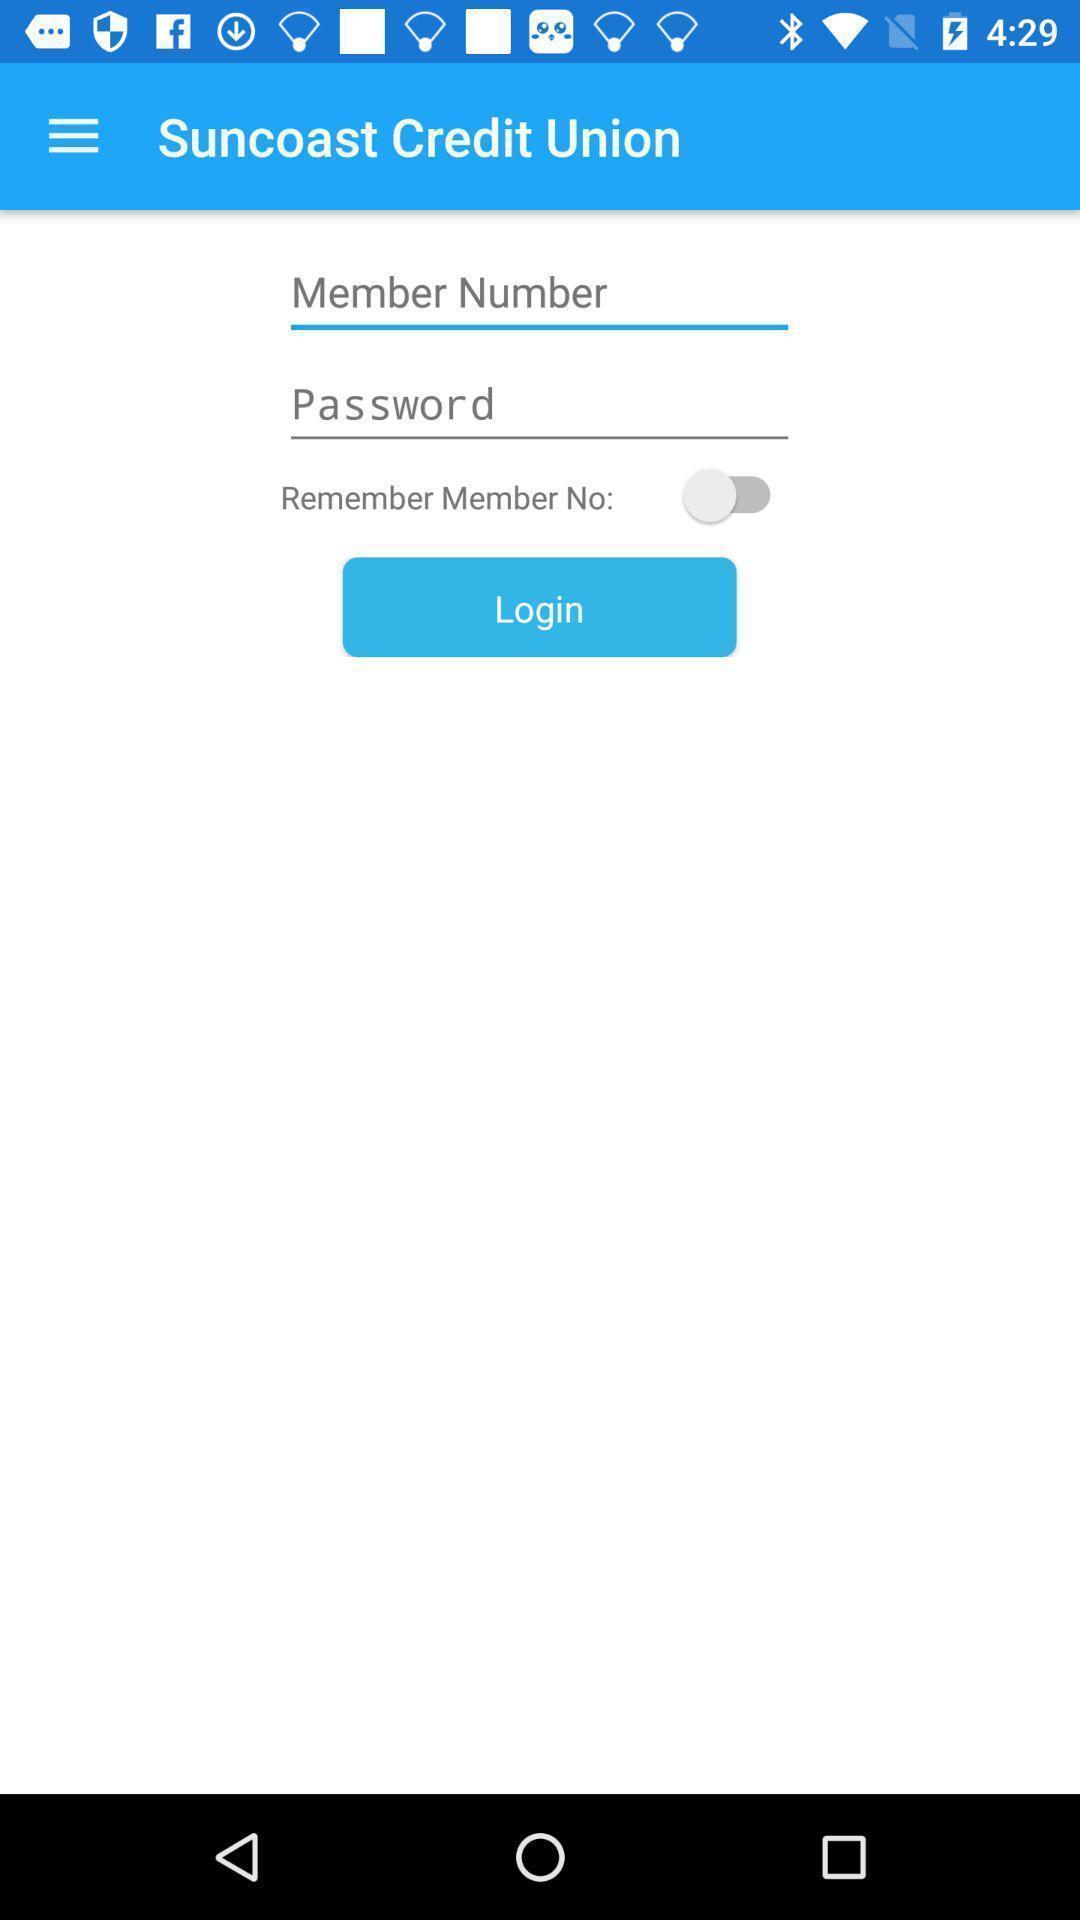Describe the visual elements of this screenshot. Login page of a banking app. 